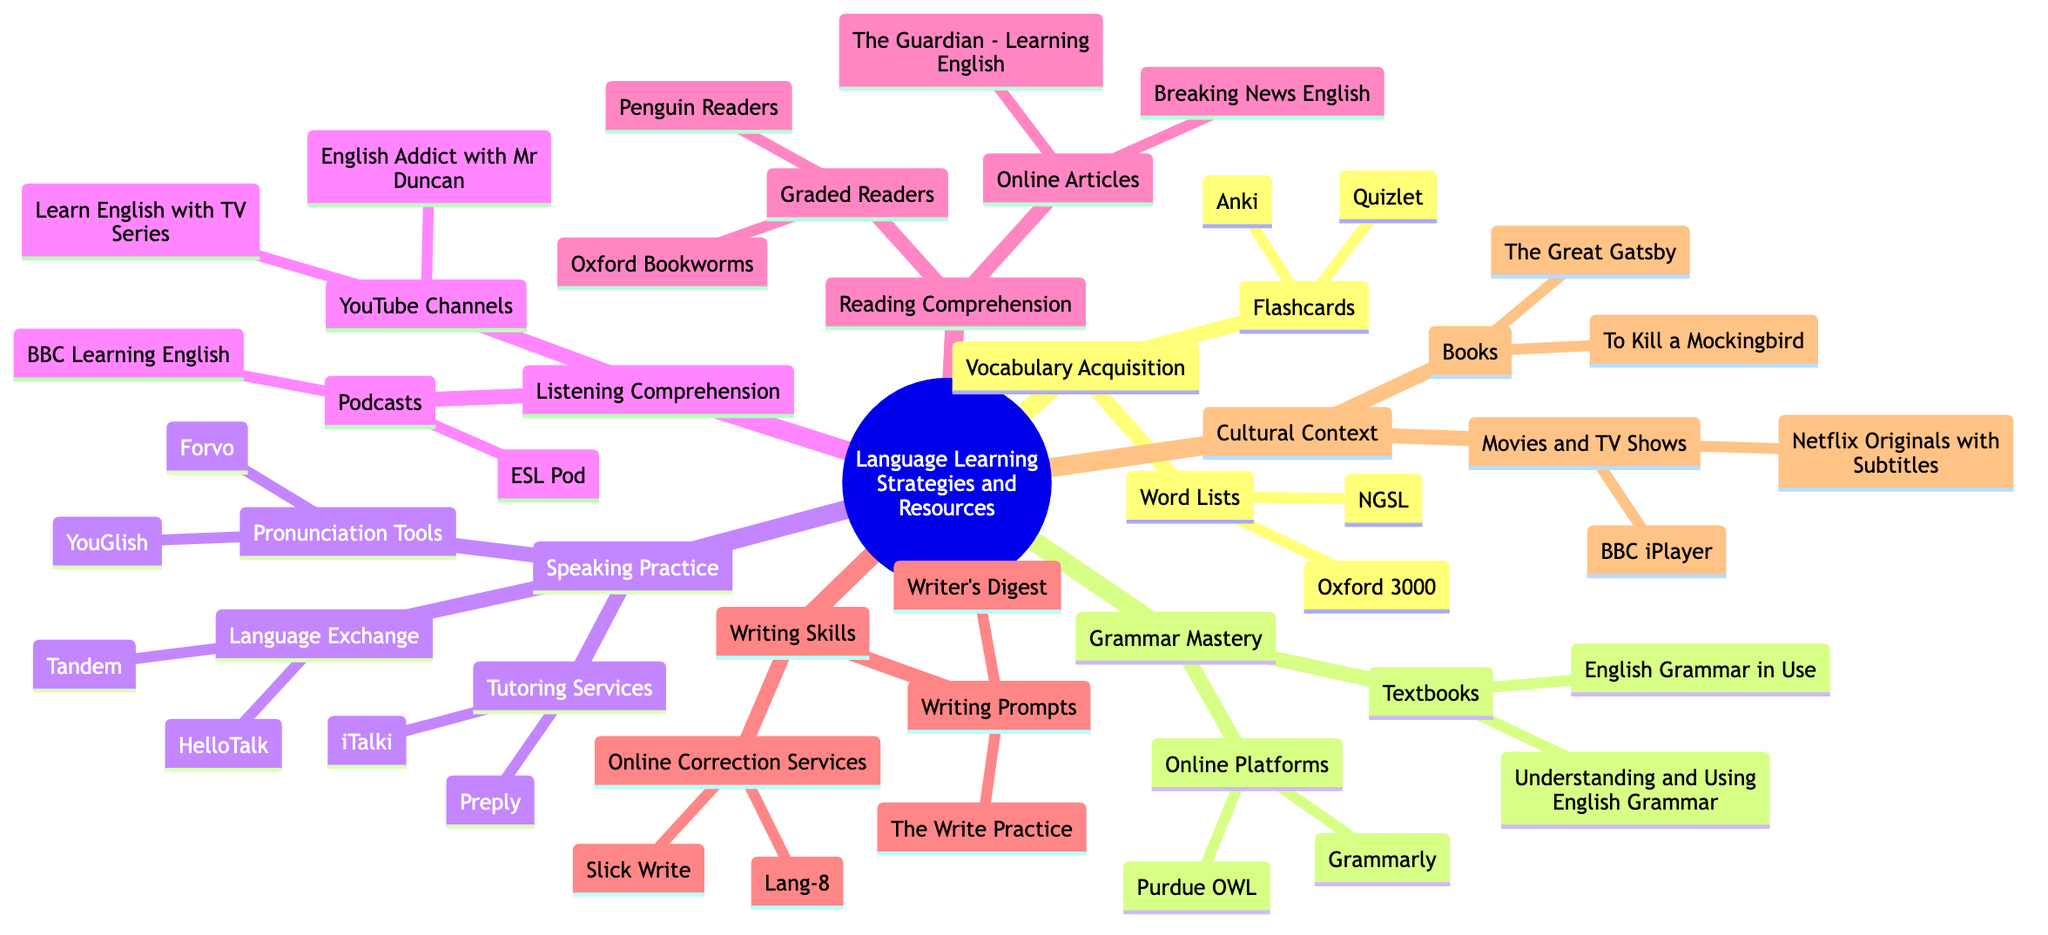What are two tools listed under Vocabulary Acquisition for flashcards? The diagram lists two specific tools under the Vocabulary Acquisition category for flashcards: Anki and Quizlet. These are both flashcard applications that help learners memorize vocabulary.
Answer: Anki, Quizlet How many categories are there under Language Learning Strategies and Resources? The diagram shows six main categories branching from Language Learning Strategies and Resources: Vocabulary Acquisition, Grammar Mastery, Speaking Practice, Listening Comprehension, Reading Comprehension, Writing Skills, and Cultural Context, totaling seven.
Answer: 7 Which type of resources can be found under Speaking Practice? In the Speaking Practice category, there are three types of resources: Language Exchange, Tutoring Services, and Pronunciation Tools. Each type has specific examples listed, such as Tandem and iTalki.
Answer: Language Exchange, Tutoring Services, Pronunciation Tools What is the first textbook mentioned in the Grammar Mastery section? The first textbook listed under the Grammar Mastery section is "English Grammar in Use by Raymond Murphy." This is a widely recognized resource for understanding English grammar.
Answer: English Grammar in Use by Raymond Murphy Which cultural resources are provided in the form of Movies and TV Shows? The diagram specifies two cultural resources under Movies and TV Shows: Netflix Originals with Subtitles and BBC iPlayer. These platforms offer access to films and television shows that can enhance cultural understanding and language skills.
Answer: Netflix Originals with Subtitles, BBC iPlayer What social media platforms can be used for Language Exchange in Speaking Practice? The two social media platforms mentioned for Language Exchange under Speaking Practice are Tandem and HelloTalk. These platforms connect language learners for conversational practice.
Answer: Tandem, HelloTalk How many specific resources are listed under Writing Skills? Under the Writing Skills category, there are two specific resources for writing prompts and online correction services. Each of these resources includes two examples, therefore there are four specific resources: The Write Practice and Writer's Digest for prompts, Lang-8 and Slick Write for correction services.
Answer: 4 Which online platforms are listed under Grammar Mastery? The two online platforms listed under Grammar Mastery are Grammarly and Purdue OWL. These platforms provide tools for grammar checking and writing assistance.
Answer: Grammarly, Purdue OWL 